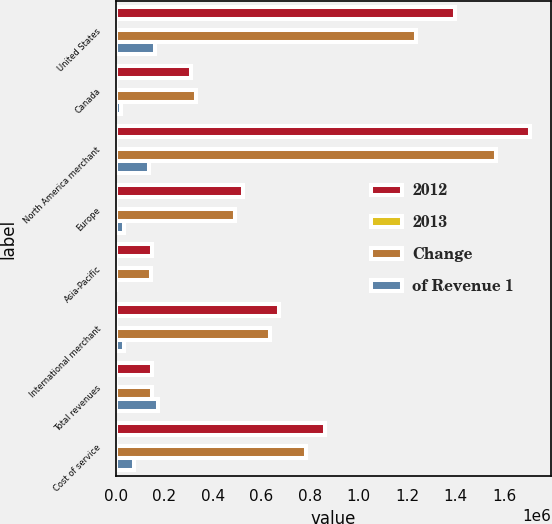Convert chart to OTSL. <chart><loc_0><loc_0><loc_500><loc_500><stacked_bar_chart><ecel><fcel>United States<fcel>Canada<fcel>North America merchant<fcel>Europe<fcel>Asia-Pacific<fcel>International merchant<fcel>Total revenues<fcel>Cost of service<nl><fcel>2012<fcel>1.39468e+06<fcel>311000<fcel>1.70568e+06<fcel>522593<fcel>147655<fcel>670248<fcel>147475<fcel>862075<nl><fcel>2013<fcel>58.7<fcel>13.1<fcel>71.8<fcel>22<fcel>6.2<fcel>28.2<fcel>100<fcel>36.3<nl><fcel>Change<fcel>1.23482e+06<fcel>332434<fcel>1.56725e+06<fcel>489300<fcel>147295<fcel>636595<fcel>147475<fcel>784756<nl><fcel>of Revenue 1<fcel>159857<fcel>21434<fcel>138423<fcel>33293<fcel>360<fcel>33653<fcel>172076<fcel>77319<nl></chart> 